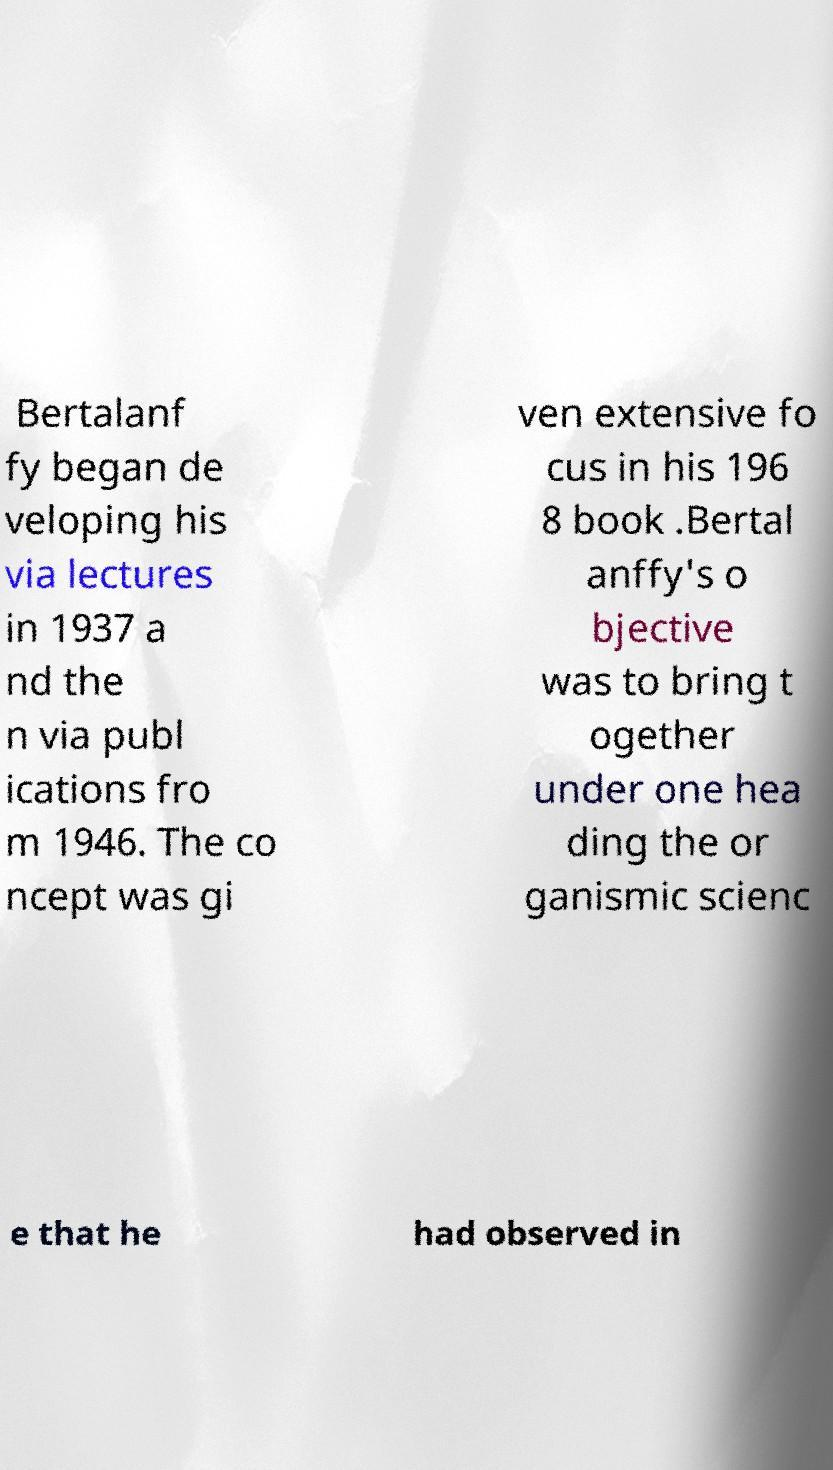What messages or text are displayed in this image? I need them in a readable, typed format. Bertalanf fy began de veloping his via lectures in 1937 a nd the n via publ ications fro m 1946. The co ncept was gi ven extensive fo cus in his 196 8 book .Bertal anffy's o bjective was to bring t ogether under one hea ding the or ganismic scienc e that he had observed in 